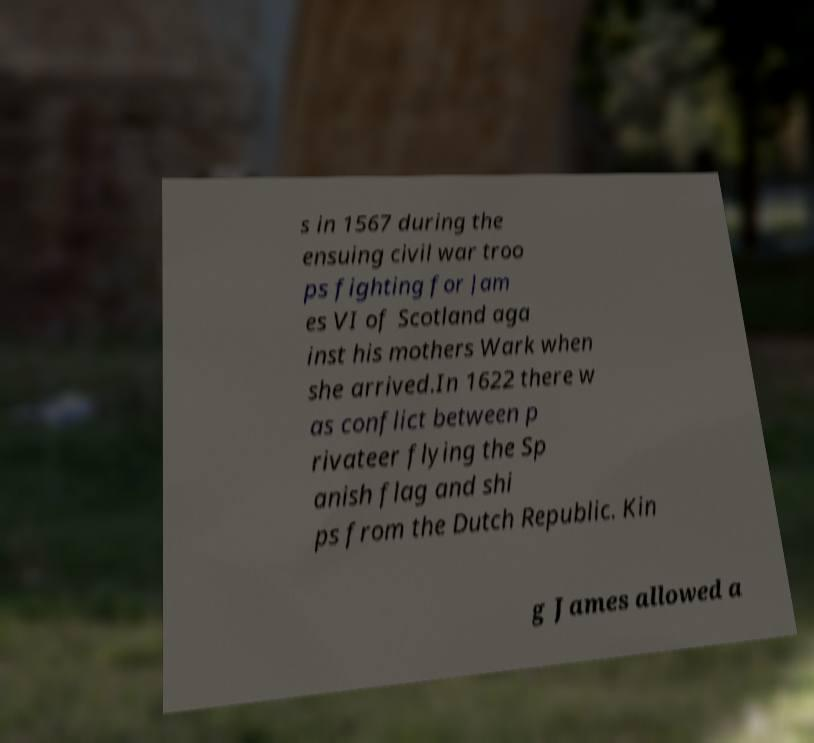Could you extract and type out the text from this image? s in 1567 during the ensuing civil war troo ps fighting for Jam es VI of Scotland aga inst his mothers Wark when she arrived.In 1622 there w as conflict between p rivateer flying the Sp anish flag and shi ps from the Dutch Republic. Kin g James allowed a 